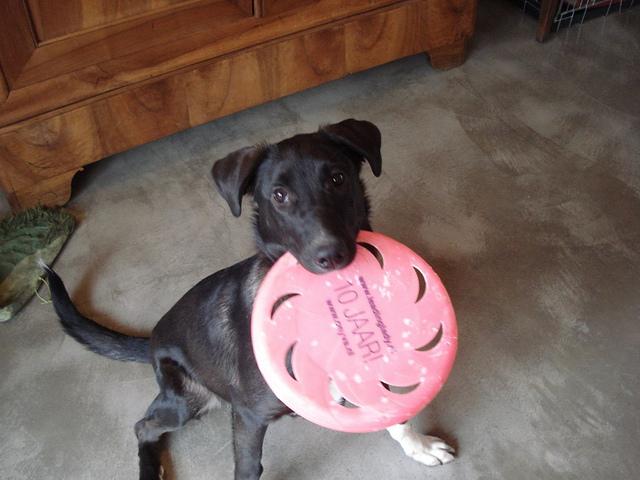Is the dog thirsty?
Be succinct. No. What animal is holding the frisbee?
Write a very short answer. Dog. Was the picture taken indoors?
Concise answer only. Yes. What sport does this dog play?
Quick response, please. Frisbee. 